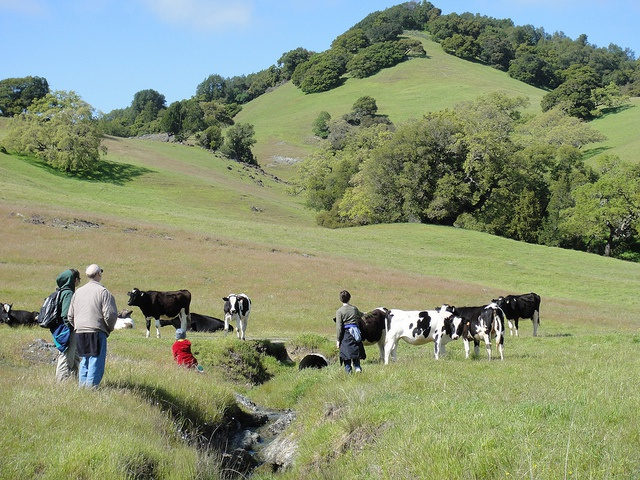Describe the objects in this image and their specific colors. I can see people in lightblue, lightgray, black, darkgray, and gray tones, cow in lightblue, white, black, gray, and darkgray tones, people in lightblue, black, gray, darkgray, and teal tones, cow in lightblue, black, gray, white, and darkgray tones, and cow in lightblue, black, gray, and darkgray tones in this image. 